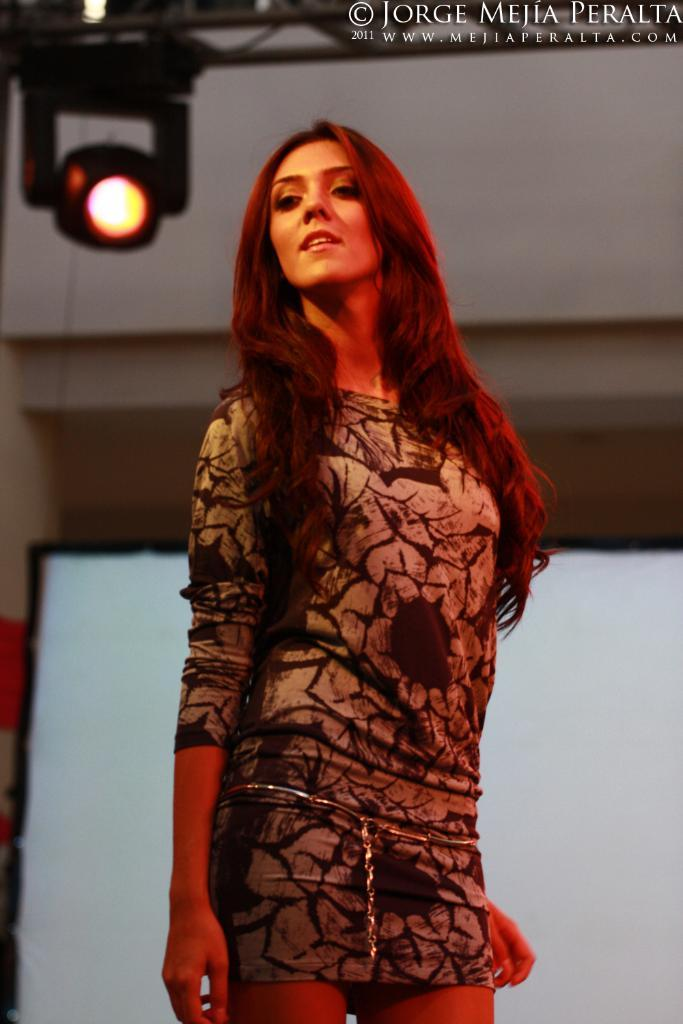Who is present in the image? There is a woman in the image. What is the woman doing in the image? The woman is standing. What can be seen behind the woman in the image? There is a light visible behind the woman. What is located in the top right hand corner of the image? There is some text in the top right hand corner of the image. What type of government is being discussed in the image? There is no discussion or mention of any government in the image. 